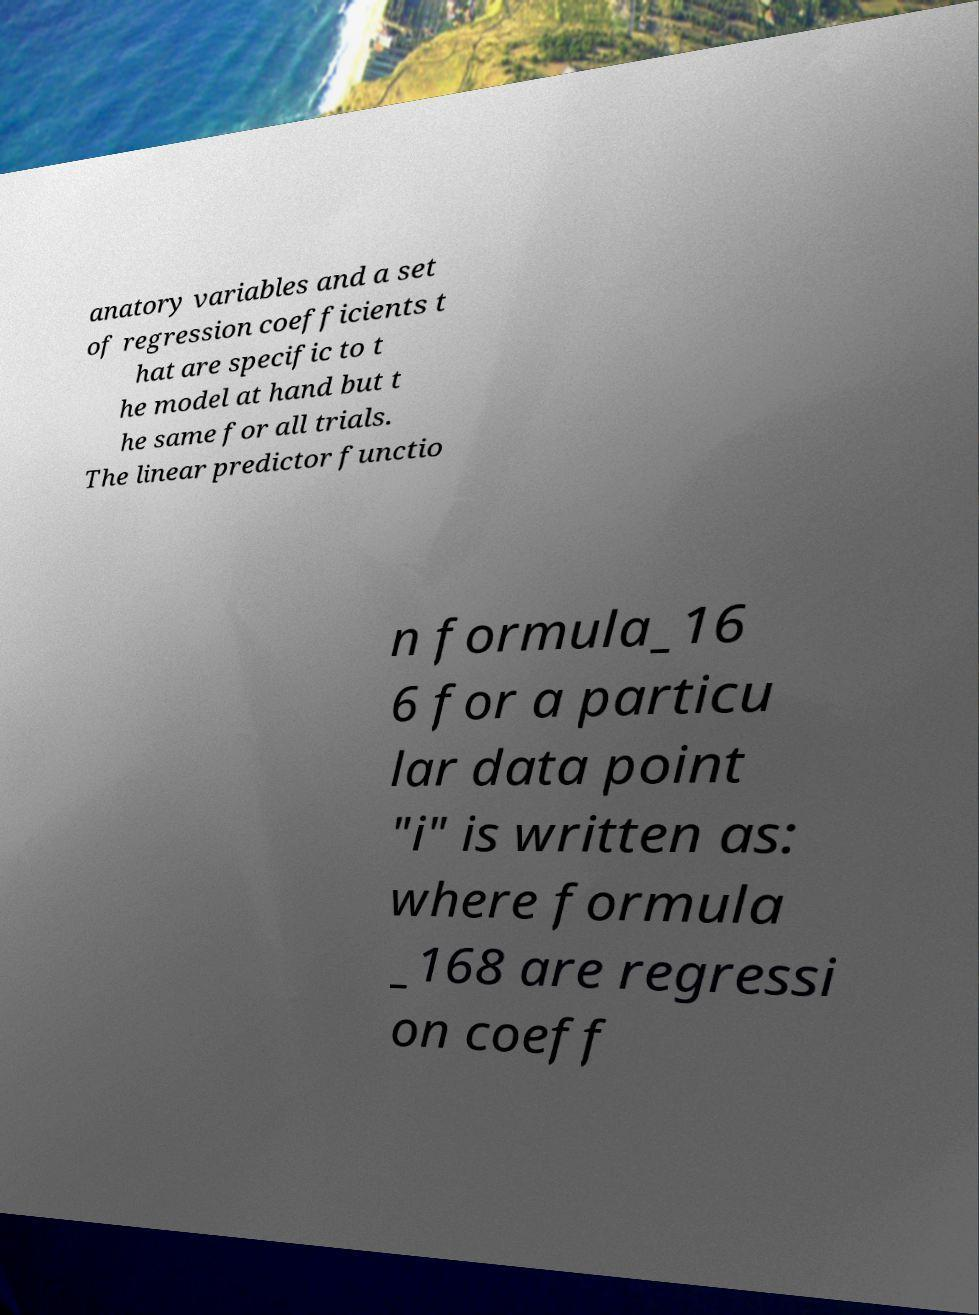There's text embedded in this image that I need extracted. Can you transcribe it verbatim? anatory variables and a set of regression coefficients t hat are specific to t he model at hand but t he same for all trials. The linear predictor functio n formula_16 6 for a particu lar data point "i" is written as: where formula _168 are regressi on coeff 